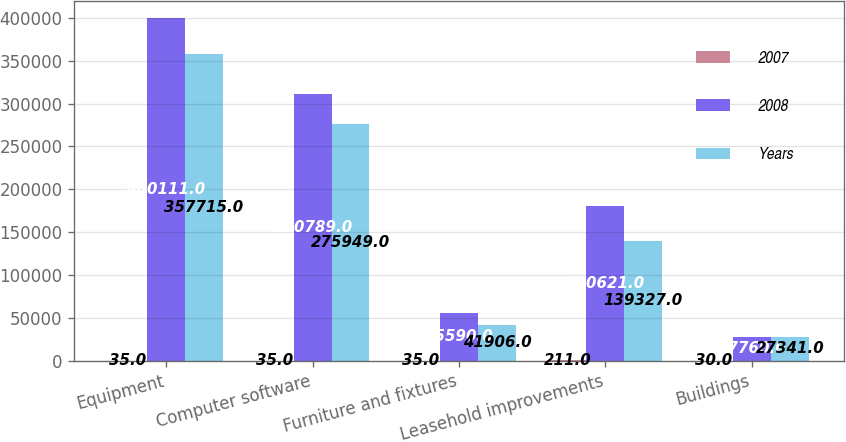Convert chart to OTSL. <chart><loc_0><loc_0><loc_500><loc_500><stacked_bar_chart><ecel><fcel>Equipment<fcel>Computer software<fcel>Furniture and fixtures<fcel>Leasehold improvements<fcel>Buildings<nl><fcel>2007<fcel>35<fcel>35<fcel>35<fcel>211<fcel>30<nl><fcel>2008<fcel>400111<fcel>310789<fcel>55590<fcel>180621<fcel>27760<nl><fcel>Years<fcel>357715<fcel>275949<fcel>41906<fcel>139327<fcel>27341<nl></chart> 